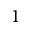Convert formula to latex. <formula><loc_0><loc_0><loc_500><loc_500>1</formula> 